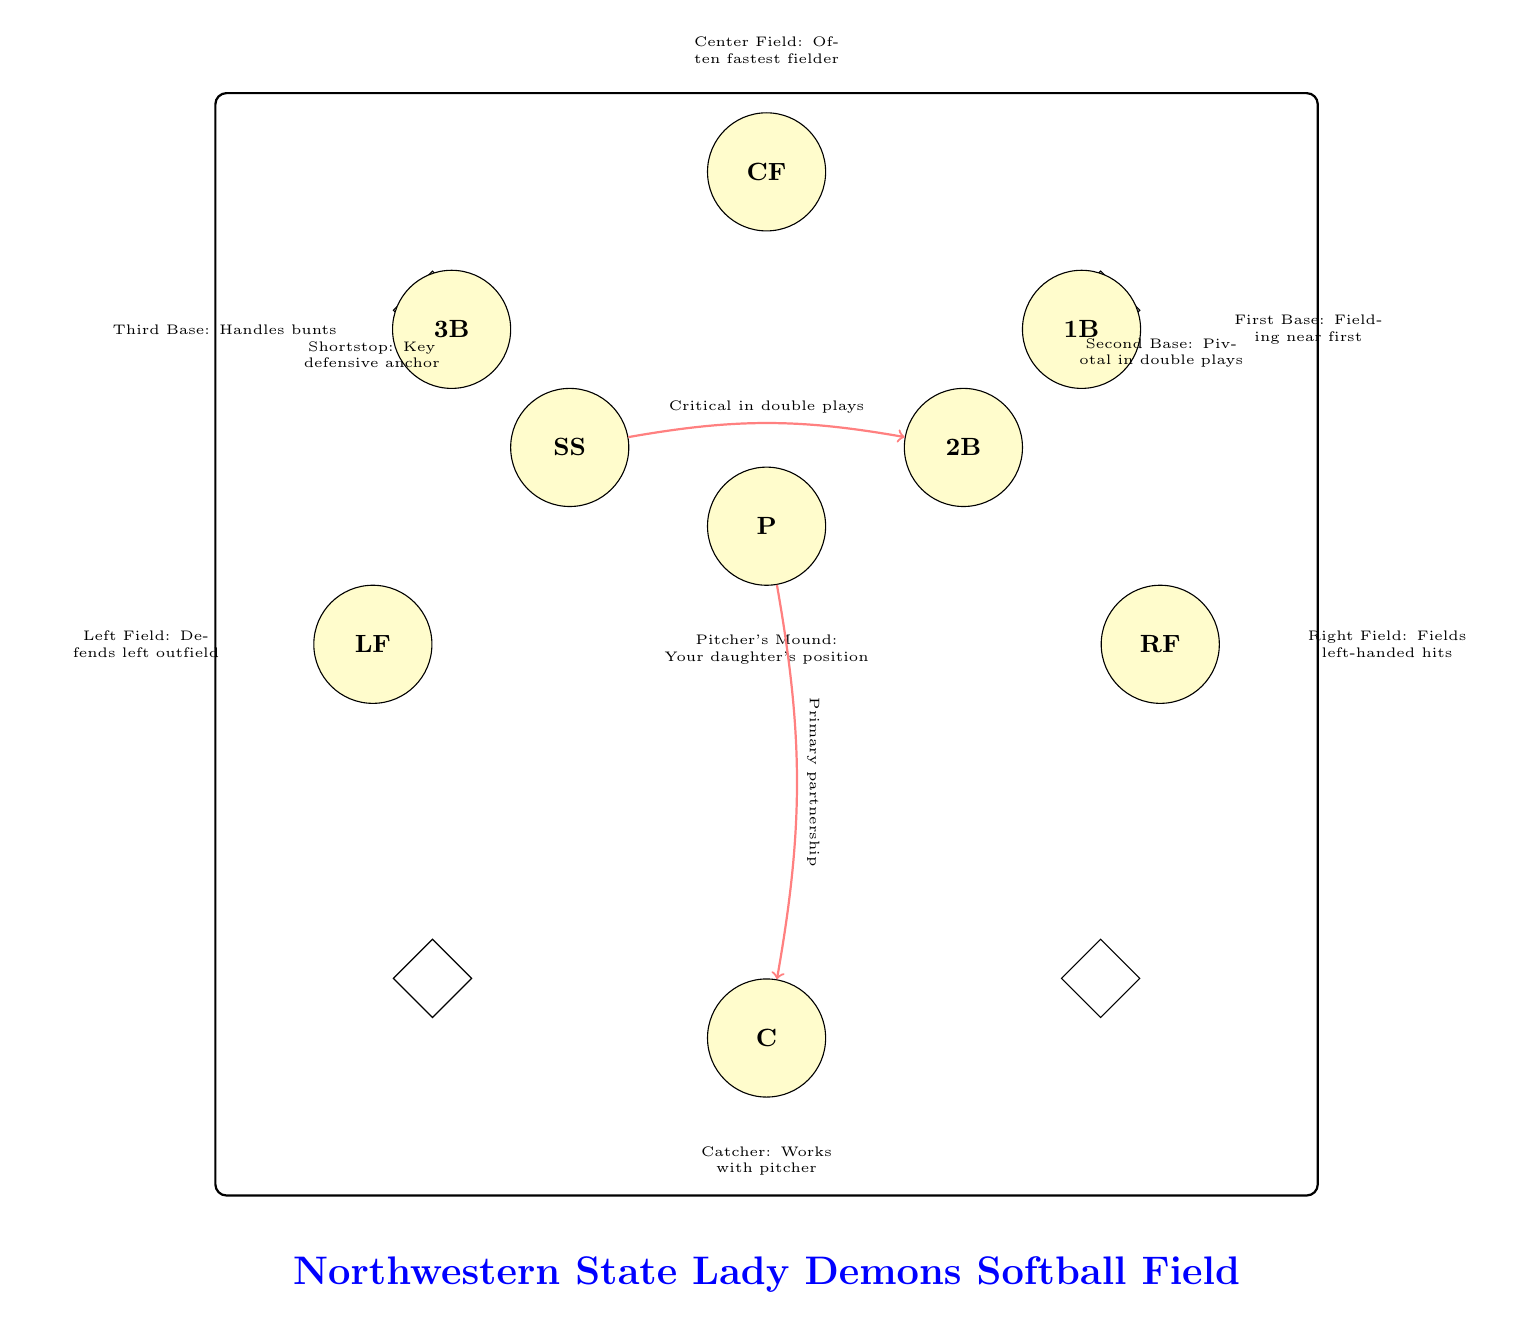What is the position of your daughter? The diagram indicates that the "P" label is located at the pitcher's mound, which is specifically stated in the description below the position. This identifies the role of the pitcher as the focal point of the team's defense.
Answer: Pitcher What role does the catcher play? The description next to the "C" node explicitly mentions that the Catcher works with the pitcher, indicating their collaborative role during the game.
Answer: Works with pitcher How many infield positions are shown in the diagram? The diagram includes all the infield positions: Pitcher, Catcher, First Base, Second Base, Shortstop, and Third Base, totaling six positions.
Answer: 6 Which position is closest to the home plate? By examining the diagram, the node labeled "C" for Catcher is positioned at the bottom center, which corresponds to the location directly behind home plate.
Answer: Catcher What position handles bunts? The description next to the "3B" node indicates that the position there is responsible for handling bunts, emphasizing the crucial role of the third baseman.
Answer: Third Base What is the critical role in double plays? The descriptions next to the "SS" and "2B" nodes mention that their roles are critical in executing double plays, indicating their defensive collaboration.
Answer: Shortstop and Second Base How many outfield positions are depicted? The diagram includes three outfield positions: Left Field, Center Field, and Right Field, which shows their respective roles and locations on the field.
Answer: 3 Which position is often the fastest fielder? The diagram's description below the "CF" node states that the Center Field position is often occupied by the fastest fielder on the team, highlighting its importance in covering the outfield.
Answer: Center Field What is the relationship between the pitcher and the catcher? The arrow labeled "Primary partnership" connects the nodes for Pitcher and Catcher, indicating their close working relationship during games, as outlined in the link's description.
Answer: Primary partnership 